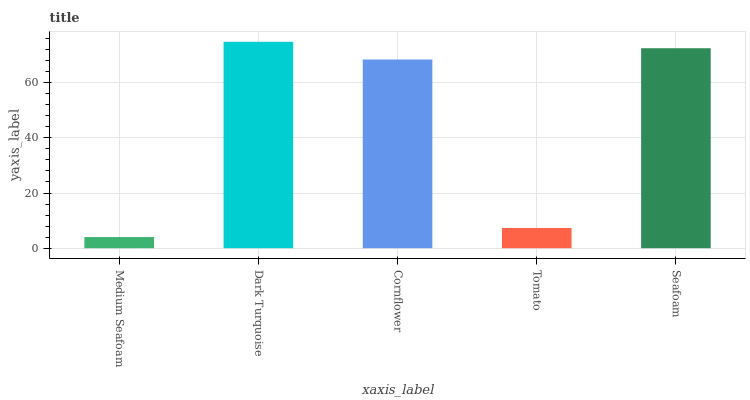Is Medium Seafoam the minimum?
Answer yes or no. Yes. Is Dark Turquoise the maximum?
Answer yes or no. Yes. Is Cornflower the minimum?
Answer yes or no. No. Is Cornflower the maximum?
Answer yes or no. No. Is Dark Turquoise greater than Cornflower?
Answer yes or no. Yes. Is Cornflower less than Dark Turquoise?
Answer yes or no. Yes. Is Cornflower greater than Dark Turquoise?
Answer yes or no. No. Is Dark Turquoise less than Cornflower?
Answer yes or no. No. Is Cornflower the high median?
Answer yes or no. Yes. Is Cornflower the low median?
Answer yes or no. Yes. Is Tomato the high median?
Answer yes or no. No. Is Medium Seafoam the low median?
Answer yes or no. No. 